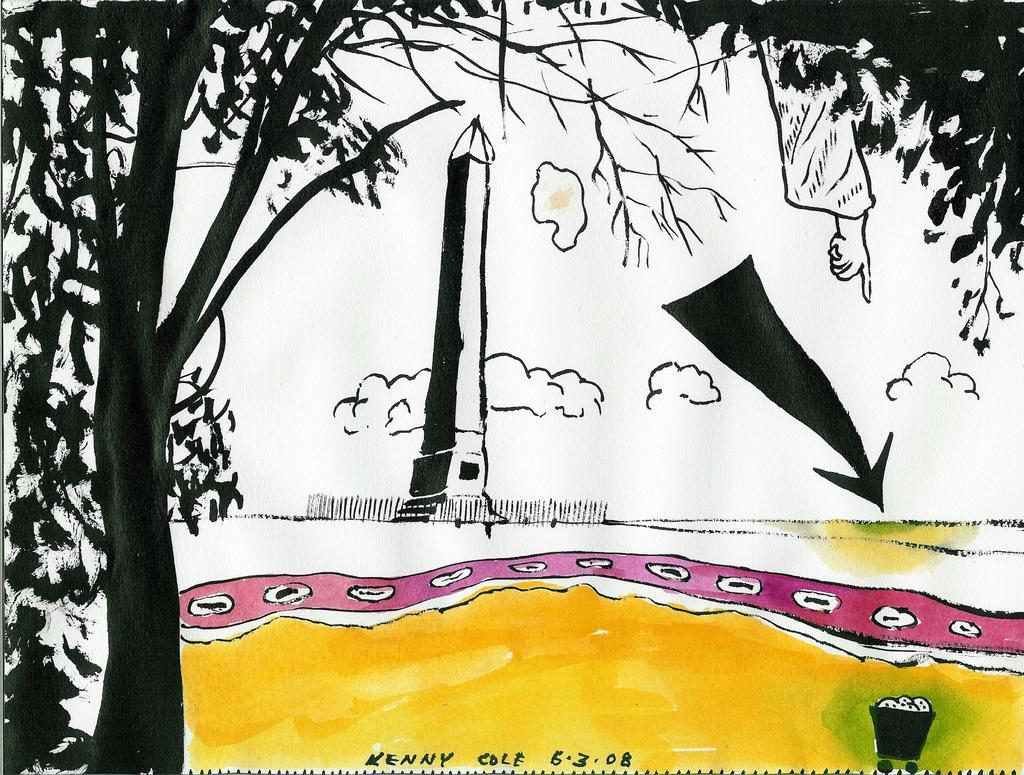Could you give a brief overview of what you see in this image? In this image we can see a painting. In the painting there are clouds, human hand, trees, tower and a trash trolley. 